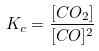<formula> <loc_0><loc_0><loc_500><loc_500>K _ { c } = \frac { [ C O _ { 2 } ] } { [ C O ] ^ { 2 } }</formula> 